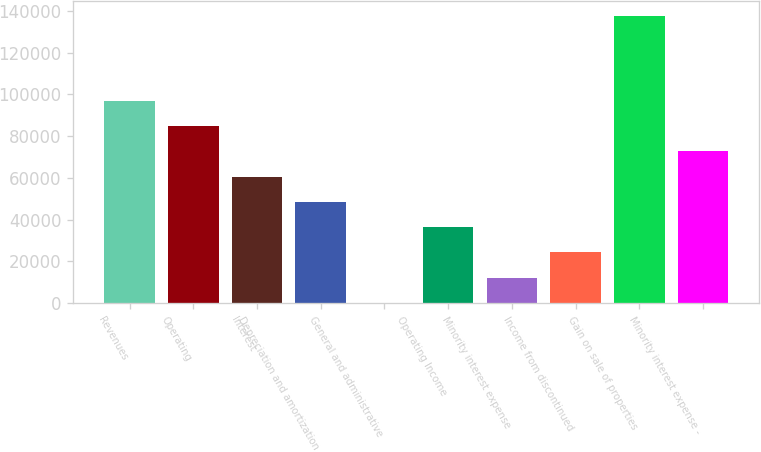Convert chart to OTSL. <chart><loc_0><loc_0><loc_500><loc_500><bar_chart><fcel>Revenues<fcel>Operating<fcel>Interest<fcel>Depreciation and amortization<fcel>General and administrative<fcel>Operating Income<fcel>Minority interest expense<fcel>Income from discontinued<fcel>Gain on sale of properties<fcel>Minority interest expense -<nl><fcel>96865.2<fcel>84761.8<fcel>60555<fcel>48451.6<fcel>38<fcel>36348.2<fcel>12141.4<fcel>24244.8<fcel>137772<fcel>72658.4<nl></chart> 